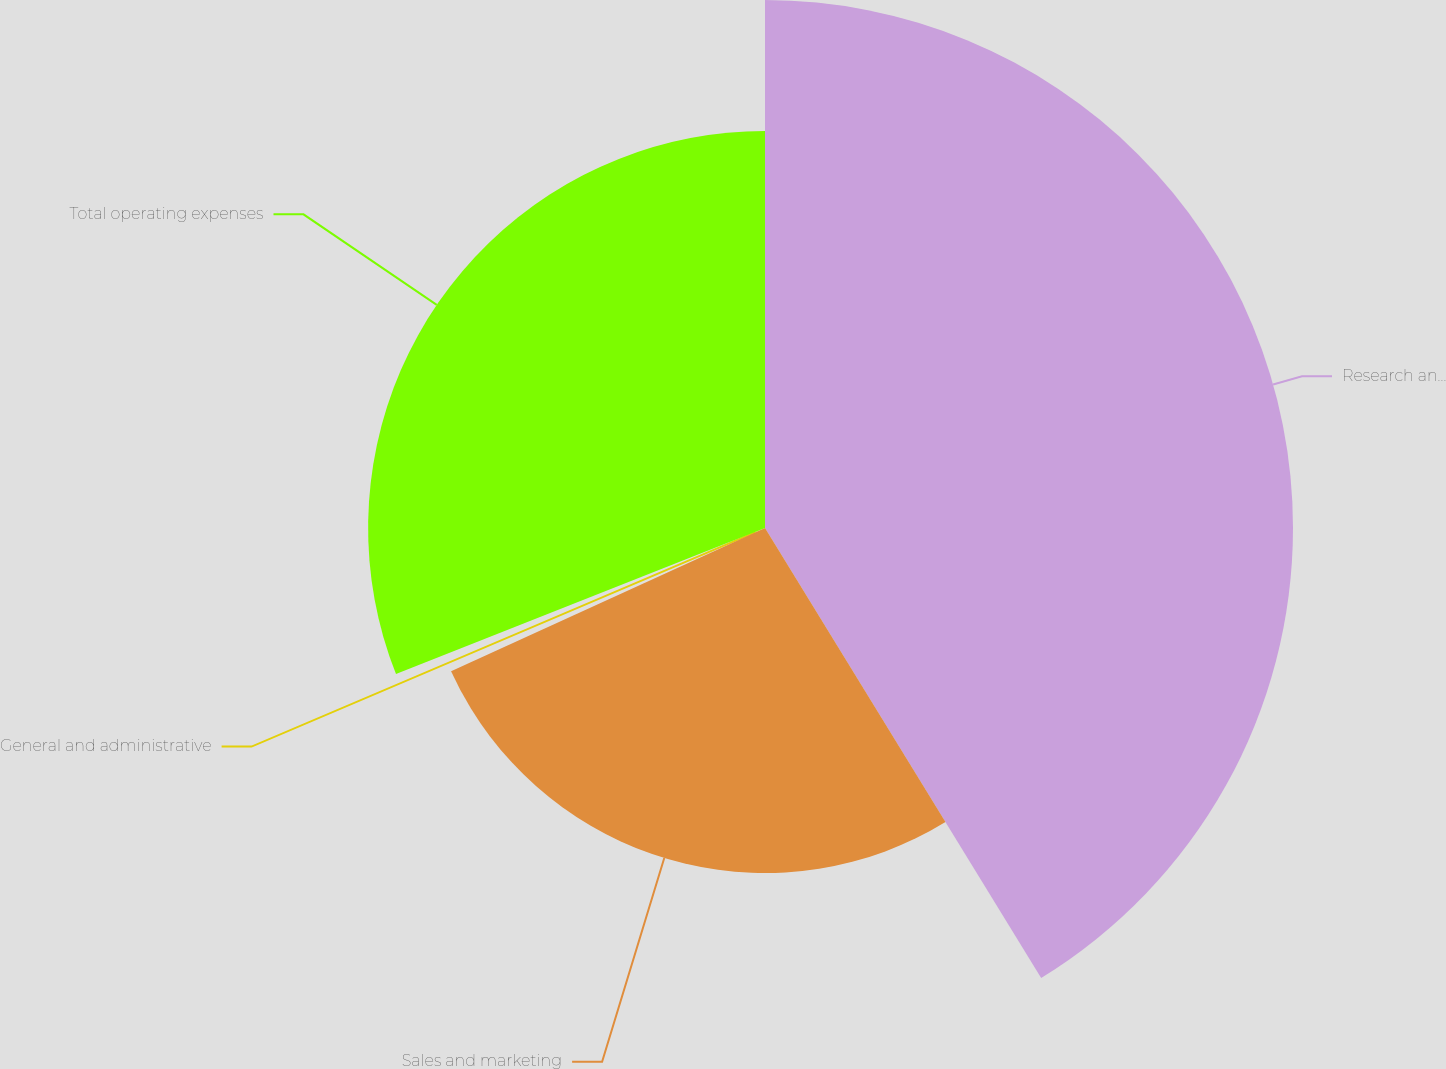Convert chart. <chart><loc_0><loc_0><loc_500><loc_500><pie_chart><fcel>Research and development<fcel>Sales and marketing<fcel>General and administrative<fcel>Total operating expenses<nl><fcel>41.24%<fcel>26.95%<fcel>0.81%<fcel>31.0%<nl></chart> 